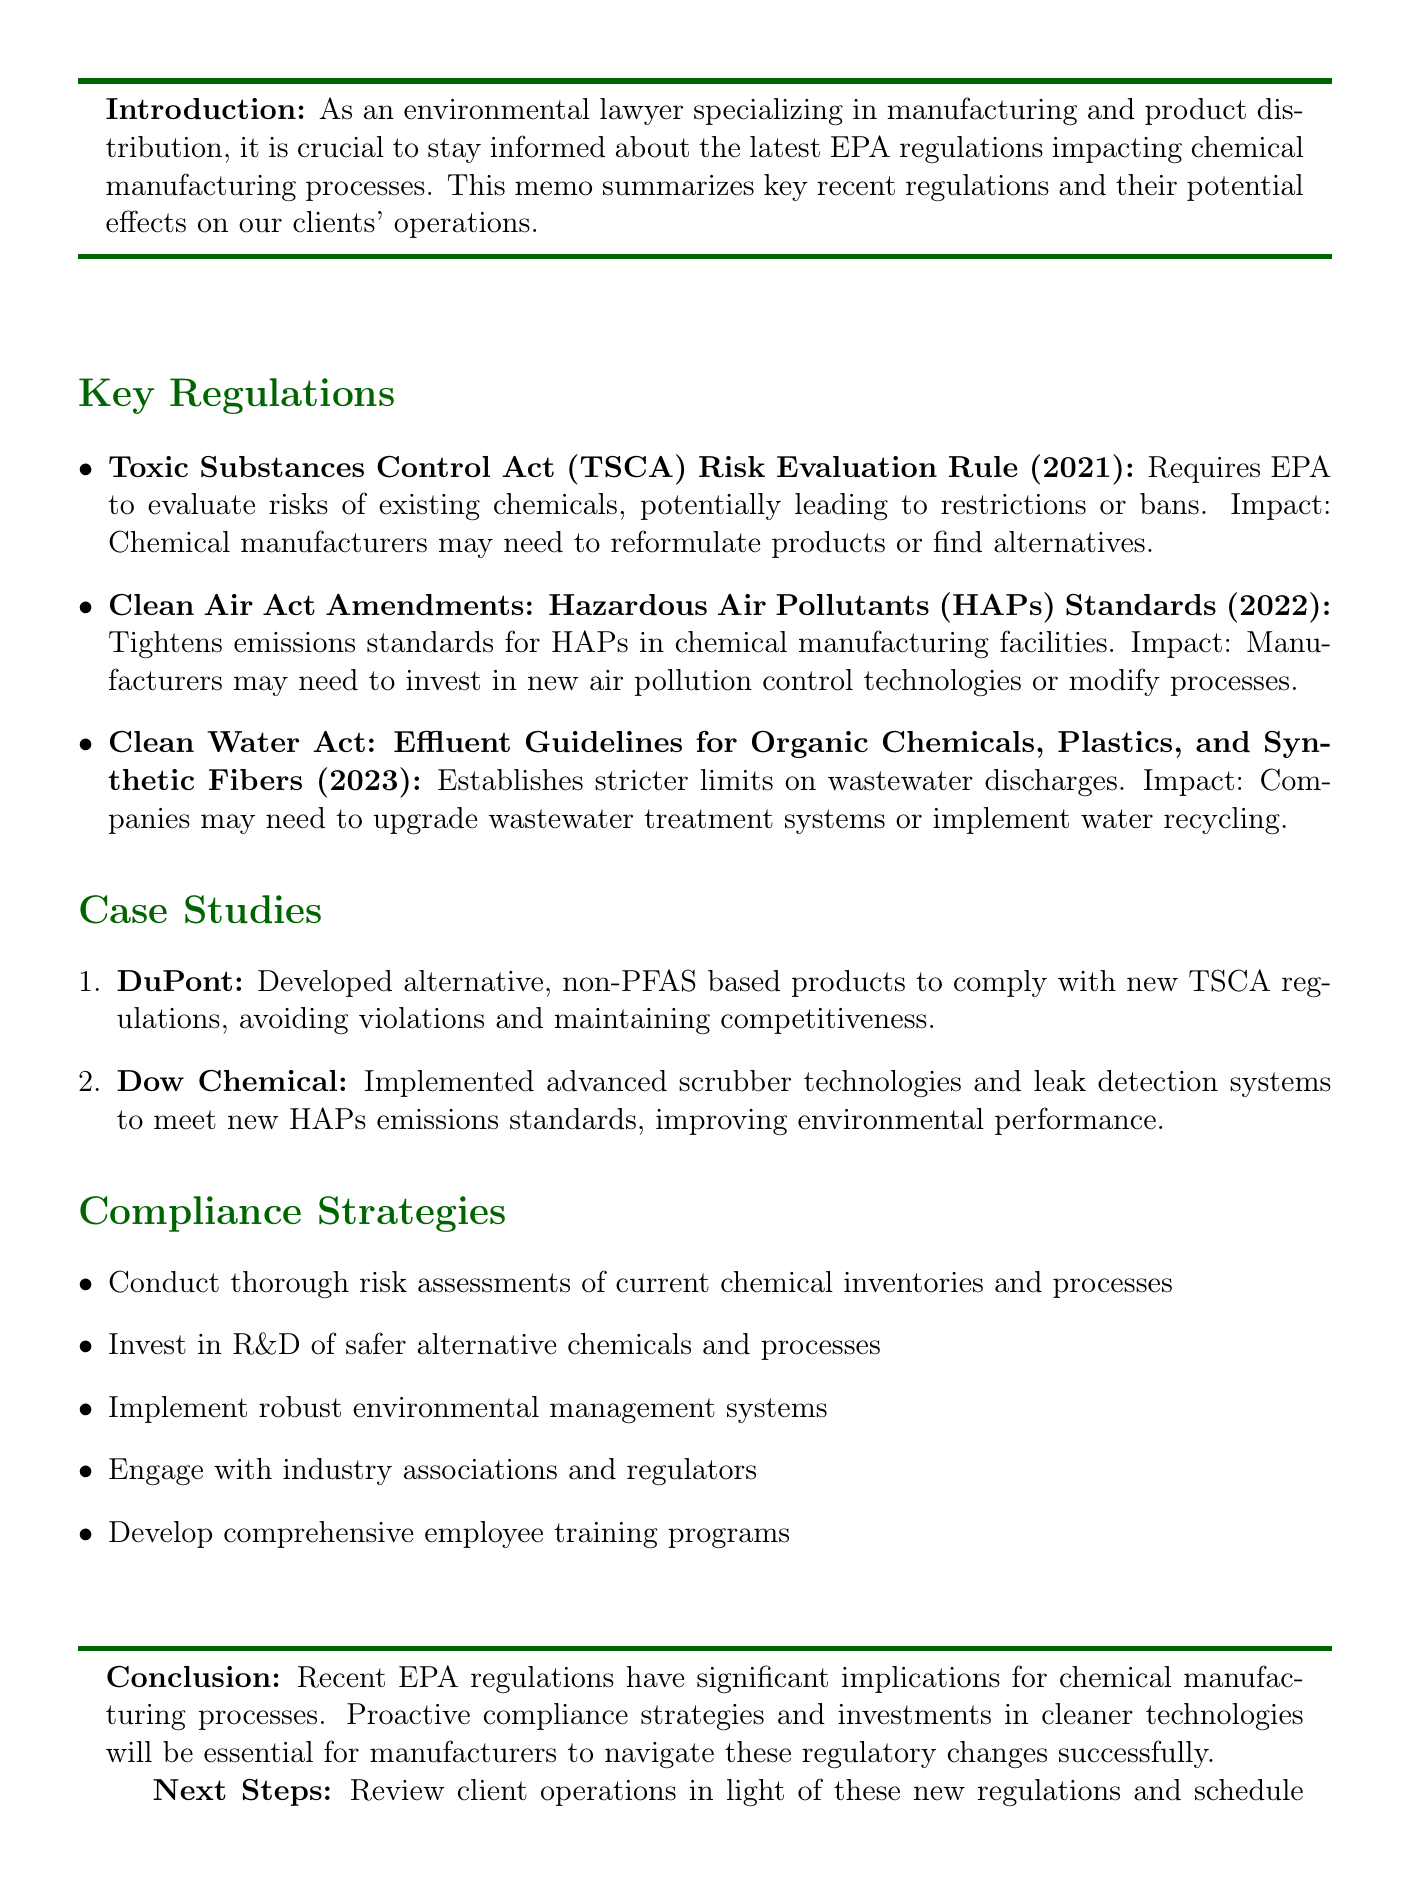What is the title of the memo? The title of the memo is stated at the beginning of the document.
Answer: Recent EPA Regulations Affecting Chemical Manufacturing Processes What year was the TSCA Risk Evaluation Rule implemented? The implementation date of the TSCA Risk Evaluation Rule is specified in its description.
Answer: 2021 Which company developed alternative non-PFAS based products? The case study section identifies the company that took this action.
Answer: DuPont What are the recent amendments to the Clean Air Act concerned with? The document specifies the focus of the Clean Air Act Amendments in the key regulations section.
Answer: Hazardous Air Pollutants (HAPs) Standards What should manufacturers invest in according to compliance strategies? The compliance strategies list suggests an area of investment for manufacturers.
Answer: Research and development of safer alternative chemicals and processes What is one potential outcome of the new HAP emissions standards for Dow Chemical? The document outlines the impact of the new standards on Dow Chemical in the case study.
Answer: Improved overall environmental performance What is a next step mentioned in the conclusion? The conclusion section outlines a recommended next step for further action.
Answer: Review client operations in light of these new regulations 